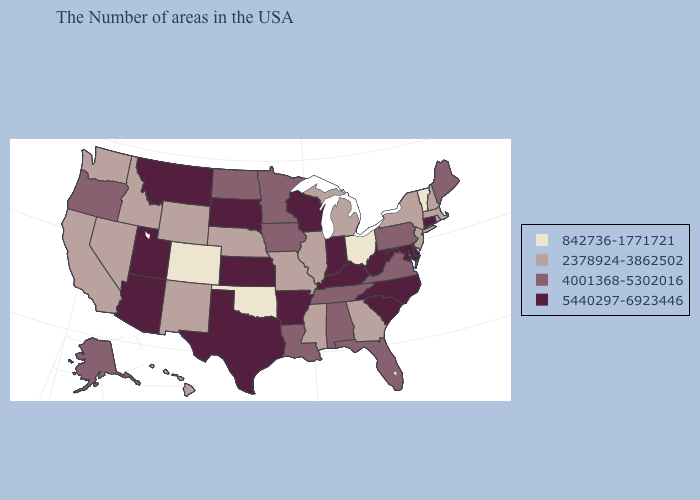Name the states that have a value in the range 4001368-5302016?
Quick response, please. Maine, Pennsylvania, Virginia, Florida, Alabama, Tennessee, Louisiana, Minnesota, Iowa, North Dakota, Oregon, Alaska. How many symbols are there in the legend?
Keep it brief. 4. What is the value of Illinois?
Be succinct. 2378924-3862502. What is the highest value in states that border Illinois?
Concise answer only. 5440297-6923446. Name the states that have a value in the range 5440297-6923446?
Concise answer only. Connecticut, Delaware, Maryland, North Carolina, South Carolina, West Virginia, Kentucky, Indiana, Wisconsin, Arkansas, Kansas, Texas, South Dakota, Utah, Montana, Arizona. What is the value of Louisiana?
Write a very short answer. 4001368-5302016. Among the states that border Tennessee , which have the highest value?
Concise answer only. North Carolina, Kentucky, Arkansas. What is the lowest value in the South?
Keep it brief. 842736-1771721. What is the value of Georgia?
Answer briefly. 2378924-3862502. Name the states that have a value in the range 5440297-6923446?
Keep it brief. Connecticut, Delaware, Maryland, North Carolina, South Carolina, West Virginia, Kentucky, Indiana, Wisconsin, Arkansas, Kansas, Texas, South Dakota, Utah, Montana, Arizona. What is the highest value in the USA?
Answer briefly. 5440297-6923446. Does Maine have a lower value than Michigan?
Answer briefly. No. Does Nebraska have the same value as Montana?
Answer briefly. No. Does Iowa have the lowest value in the USA?
Answer briefly. No. 